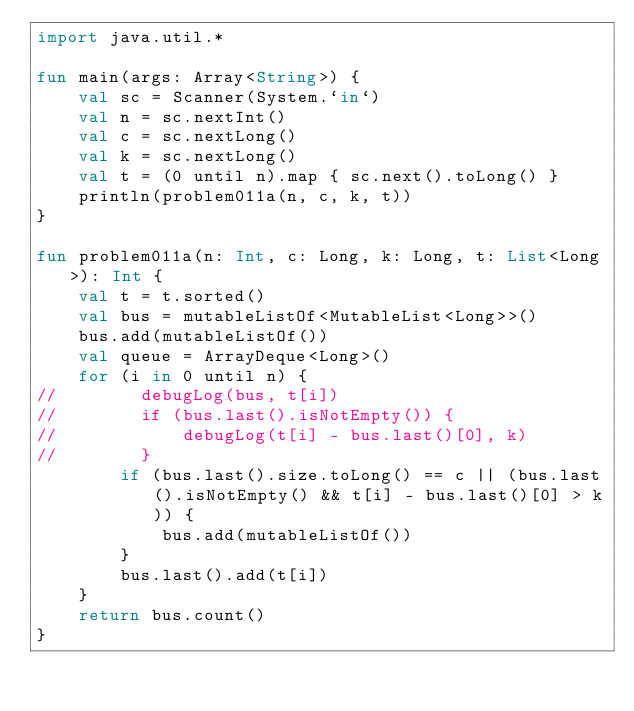Convert code to text. <code><loc_0><loc_0><loc_500><loc_500><_Kotlin_>import java.util.*

fun main(args: Array<String>) {
    val sc = Scanner(System.`in`)
    val n = sc.nextInt()
    val c = sc.nextLong()
    val k = sc.nextLong()
    val t = (0 until n).map { sc.next().toLong() }
    println(problem011a(n, c, k, t))
}

fun problem011a(n: Int, c: Long, k: Long, t: List<Long>): Int {
    val t = t.sorted()
    val bus = mutableListOf<MutableList<Long>>()
    bus.add(mutableListOf())
    val queue = ArrayDeque<Long>()
    for (i in 0 until n) {
//        debugLog(bus, t[i])
//        if (bus.last().isNotEmpty()) {
//            debugLog(t[i] - bus.last()[0], k)
//        }
        if (bus.last().size.toLong() == c || (bus.last().isNotEmpty() && t[i] - bus.last()[0] > k)) {
            bus.add(mutableListOf())
        }
        bus.last().add(t[i])
    }
    return bus.count()
}
</code> 